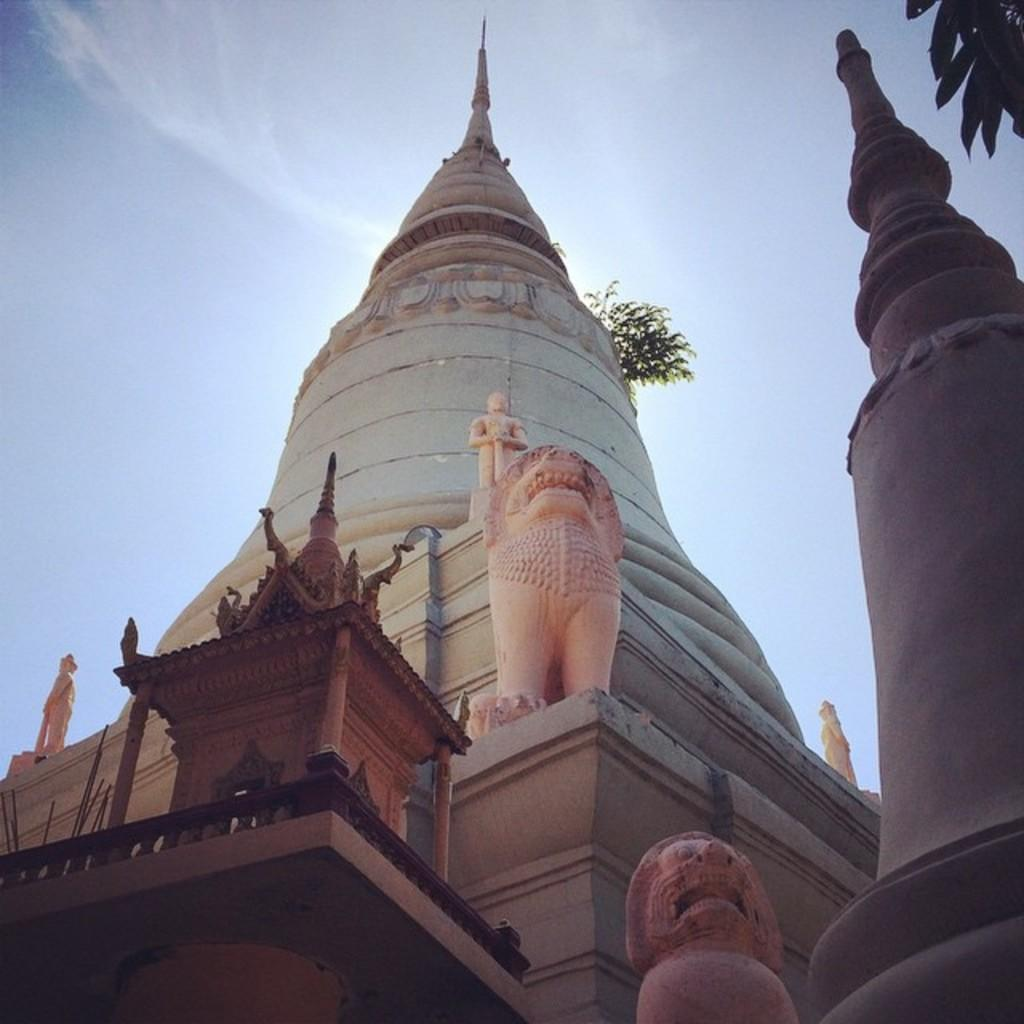What type of structure is visible in the image? There is a building in the image. What other objects can be seen near the building? There are statues in the image. What type of vegetation is present in the image? Leaves are present in the image. What can be seen in the distance in the image? The sky is visible in the background of the image. What riddle is being solved by the train in the image? There is no train present in the image, so no riddle is being solved. 